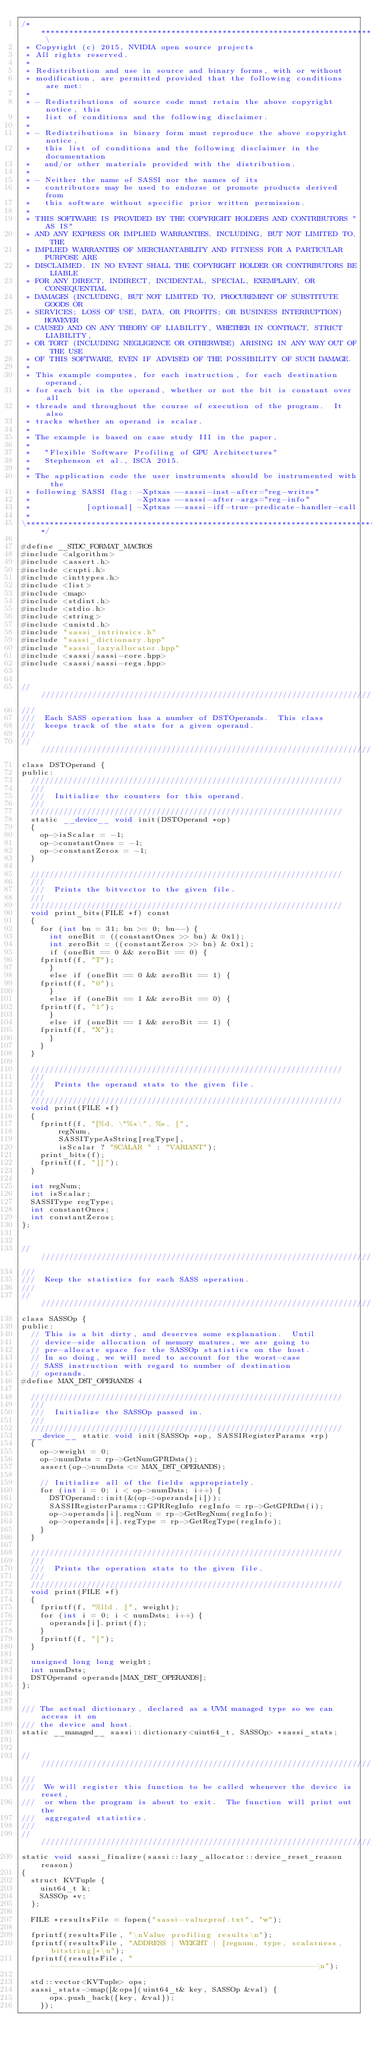Convert code to text. <code><loc_0><loc_0><loc_500><loc_500><_Cuda_>/*********************************************************************************** \
 * Copyright (c) 2015, NVIDIA open source projects
 * All rights reserved.
 * 
 * Redistribution and use in source and binary forms, with or without
 * modification, are permitted provided that the following conditions are met:
 * 
 * - Redistributions of source code must retain the above copyright notice, this
 *   list of conditions and the following disclaimer.
 * 
 * - Redistributions in binary form must reproduce the above copyright notice,
 *   this list of conditions and the following disclaimer in the documentation
 *   and/or other materials provided with the distribution.
 * 
 * - Neither the name of SASSI nor the names of its
 *   contributors may be used to endorse or promote products derived from
 *   this software without specific prior written permission.
 * 
 * THIS SOFTWARE IS PROVIDED BY THE COPYRIGHT HOLDERS AND CONTRIBUTORS "AS IS"
 * AND ANY EXPRESS OR IMPLIED WARRANTIES, INCLUDING, BUT NOT LIMITED TO, THE
 * IMPLIED WARRANTIES OF MERCHANTABILITY AND FITNESS FOR A PARTICULAR PURPOSE ARE
 * DISCLAIMED. IN NO EVENT SHALL THE COPYRIGHT HOLDER OR CONTRIBUTORS BE LIABLE
 * FOR ANY DIRECT, INDIRECT, INCIDENTAL, SPECIAL, EXEMPLARY, OR CONSEQUENTIAL
 * DAMAGES (INCLUDING, BUT NOT LIMITED TO, PROCUREMENT OF SUBSTITUTE GOODS OR
 * SERVICES; LOSS OF USE, DATA, OR PROFITS; OR BUSINESS INTERRUPTION) HOWEVER
 * CAUSED AND ON ANY THEORY OF LIABILITY, WHETHER IN CONTRACT, STRICT LIABILITY,
 * OR TORT (INCLUDING NEGLIGENCE OR OTHERWISE) ARISING IN ANY WAY OUT OF THE USE
 * OF THIS SOFTWARE, EVEN IF ADVISED OF THE POSSIBILITY OF SUCH DAMAGE.
 *
 * This example computes, for each instruction, for each destination operand,
 * for each bit in the operand, whether or not the bit is constant over all
 * threads and throughout the course of execution of the program.  It also
 * tracks whether an operand is scalar.  
 *
 * The example is based on case study III in the paper,
 *
 *   "Flexible Software Profiling of GPU Architectures"
 *   Stephenson et al., ISCA 2015.
 *
 * The application code the user instruments should be instrumented with the
 * following SASSI flag: -Xptxas --sassi-inst-after="reg-writes"
 *                       -Xptxas --sassi-after-args="reg-info"
 *            [optional] -Xptxas --sassi-iff-true-predicate-handler-call
 *  
\***********************************************************************************/

#define __STDC_FORMAT_MACROS
#include <algorithm>
#include <assert.h>
#include <cupti.h>
#include <inttypes.h>
#include <list>
#include <map>
#include <stdint.h>
#include <stdio.h>
#include <string>
#include <unistd.h>
#include "sassi_intrinsics.h"
#include "sassi_dictionary.hpp"
#include "sassi_lazyallocator.hpp"
#include <sassi/sassi-core.hpp>
#include <sassi/sassi-regs.hpp>


///////////////////////////////////////////////////////////////////////////////////
///  
///  Each SASS operation has a number of DSTOperands.  This class
///  keeps track of the stats for a given operand.
///
///////////////////////////////////////////////////////////////////////////////////
class DSTOperand {
public:
  ///////////////////////////////////////////////////////////////////
  ///  
  ///  Initialize the counters for this operand.
  ///
  ///////////////////////////////////////////////////////////////////
  static __device__ void init(DSTOperand *op)
  {
    op->isScalar = -1;
    op->constantOnes = -1;
    op->constantZeros = -1;
  }

  ///////////////////////////////////////////////////////////////////
  ///  
  ///  Prints the bitvector to the given file.
  ///
  ///////////////////////////////////////////////////////////////////
  void print_bits(FILE *f) const
  {
    for (int bn = 31; bn >= 0; bn--) {
      int oneBit = ((constantOnes >> bn) & 0x1);
      int zeroBit = ((constantZeros >> bn) & 0x1);
      if (oneBit == 0 && zeroBit == 0) {
	fprintf(f, "T");
      }
      else if (oneBit == 0 && zeroBit == 1) {
	fprintf(f, "0"); 
      }
      else if (oneBit == 1 && zeroBit == 0) {
	fprintf(f, "1"); 
      }
      else if (oneBit == 1 && zeroBit == 1) {
	fprintf(f, "X");
      }
    }
  }

  ///////////////////////////////////////////////////////////////////
  ///  
  ///  Prints the operand stats to the given file.
  ///
  ///////////////////////////////////////////////////////////////////
  void print(FILE *f)
  {
    fprintf(f, "[%d, \"%s\", %s, [", 
	    regNum, 
	    SASSITypeAsString[regType],
	    isScalar ? "SCALAR " : "VARIANT");
    print_bits(f);
    fprintf(f, "]]");
  }
  
  int regNum;
  int isScalar;
  SASSIType regType;
  int constantOnes;
  int constantZeros;
};


///////////////////////////////////////////////////////////////////////////////////
///  
///  Keep the statistics for each SASS operation.
///
///////////////////////////////////////////////////////////////////////////////////
class SASSOp {
public:
  // This is a bit dirty, and deserves some explanation.  Until
  // device-side allocation of memory matures, we are going to
  // pre-allocate space for the SASSOp statistics on the host.
  // In so doing, we will need to account for the worst-case
  // SASS instruction with regard to number of destination 
  // operands. 
#define MAX_DST_OPERANDS 4

  ///////////////////////////////////////////////////////////////////
  ///  
  ///  Initialize the SASSOp passed in.
  ///
  ///////////////////////////////////////////////////////////////////
  __device__ static void init(SASSOp *op, SASSIRegisterParams *rp)
  {
    op->weight = 0;
    op->numDsts = rp->GetNumGPRDsts();
    assert(op->numDsts <= MAX_DST_OPERANDS);

    // Initialize all of the fields appropriately.
    for (int i = 0; i < op->numDsts; i++) {
      DSTOperand::init(&(op->operands[i]));
      SASSIRegisterParams::GPRRegInfo regInfo = rp->GetGPRDst(i);
      op->operands[i].regNum = rp->GetRegNum(regInfo);
      op->operands[i].regType = rp->GetRegType(regInfo);
    }
  }
  
  ///////////////////////////////////////////////////////////////////
  ///  
  ///  Prints the operation stats to the given file.
  ///
  ///////////////////////////////////////////////////////////////////
  void print(FILE *f)
  {
    fprintf(f, "%lld, [", weight);
    for (int i = 0; i < numDsts; i++) {
      operands[i].print(f);
    }
    fprintf(f, "]");
  }
  
  unsigned long long weight;
  int numDsts;
  DSTOperand operands[MAX_DST_OPERANDS];
};


/// The actual dictionary, declared as a UVM managed type so we can access it on 
/// the device and host.
static __managed__ sassi::dictionary<uint64_t, SASSOp> *sassi_stats;


///////////////////////////////////////////////////////////////////////////////////
///  
///  We will register this function to be called whenever the device is reset, 
///  or when the program is about to exit.  The function will print out the 
///  aggregated statistics.
///
///////////////////////////////////////////////////////////////////////////////////
static void sassi_finalize(sassi::lazy_allocator::device_reset_reason reason)
{
  struct KVTuple {
    uint64_t k;
    SASSOp *v;
  };

  FILE *resultsFile = fopen("sassi-valueprof.txt", "w");
  
  fprintf(resultsFile, "\nValue profiling results\n");
  fprintf(resultsFile, "ADDRESS | WEIGHT | [regnum, type, scalarness, bitstring]*\n");
  fprintf(resultsFile, "---------------------------------------------------------\n");
  
  std::vector<KVTuple> ops;
  sassi_stats->map([&ops](uint64_t& key, SASSOp &val) {
      ops.push_back({key, &val});
    });
  </code> 